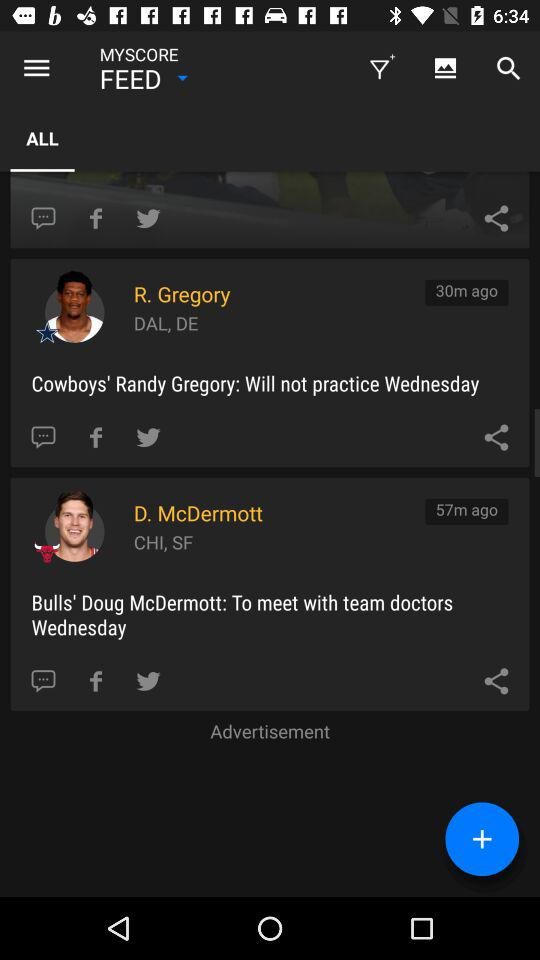How many more minutes ago was the update for D. McDermott than R. Gregory?
Answer the question using a single word or phrase. 27 